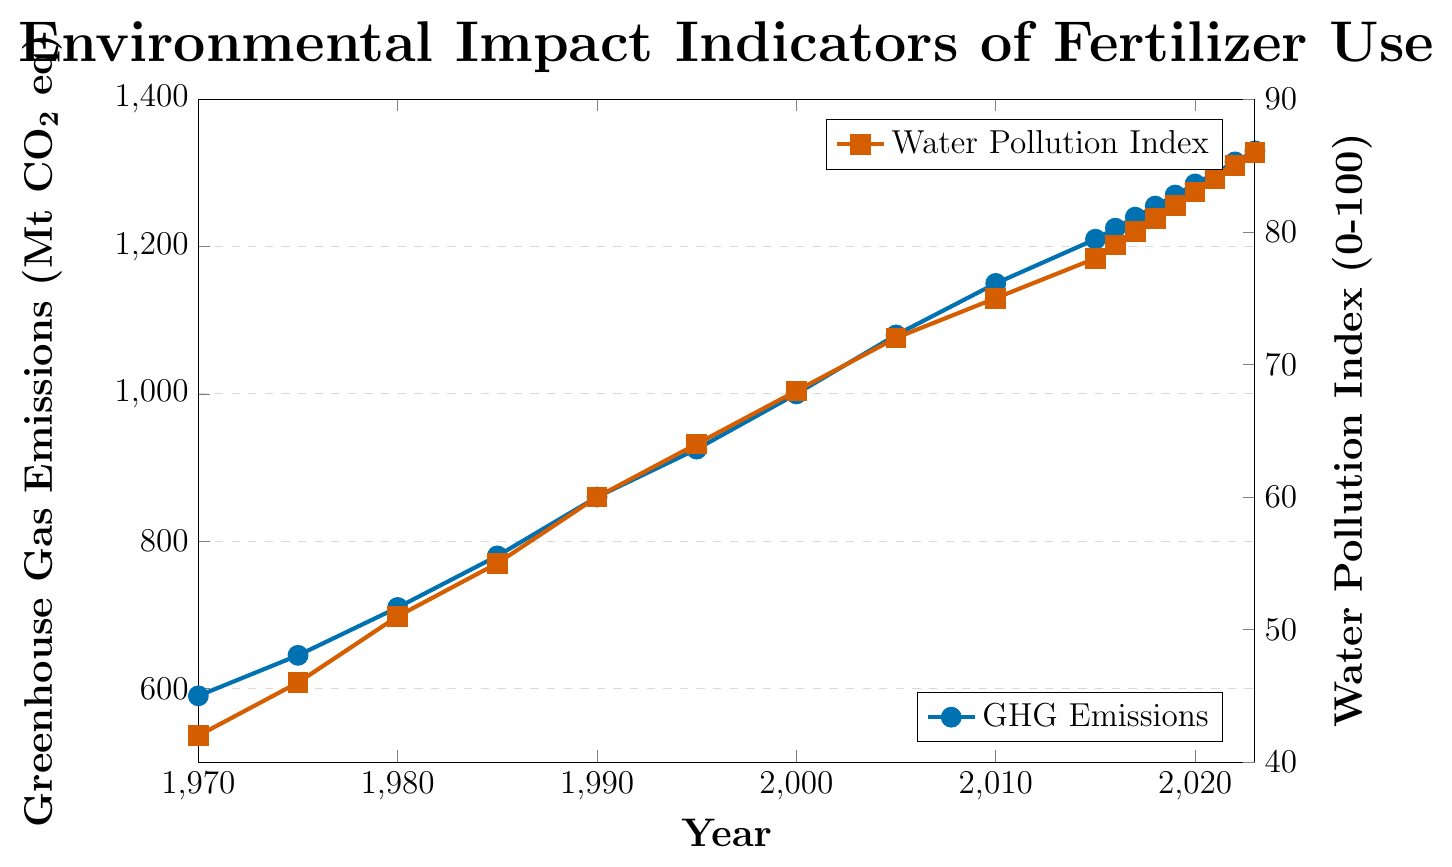What's the increase in Greenhouse Gas Emissions from 1970 to 2023? The Greenhouse Gas Emissions in 1970 was 590 Mt CO2 eq and in 2023 it was 1330 Mt CO2 eq. The increase is calculated as 1330 - 590 = 740 Mt CO2 eq.
Answer: 740 Mt CO2 eq How much did the Water Pollution Index increase from 2005 to 2023? The Water Pollution Index in 2005 was 72, and in 2023 it was 86. The increase is calculated as 86 - 72 = 14.
Answer: 14 What is the average Greenhouse Gas Emissions between 1990 and 2000? Adding the emissions from each year between 1990 and 2000 and then dividing by the number of years: (860 + 925 + 1000) / 3 = 2785 / 3 = 928.33 Mt CO2 eq
Answer: 928.33 Mt CO2 eq In which year did the Water Pollution Index first reach 60? By looking at the chart, the Water Pollution Index first reached 60 in the year 1990.
Answer: 1990 Compare the trend of Greenhouse Gas Emissions and the Water Pollution Index between 2015 and 2023. From 2015 to 2023, Greenhouse Gas Emissions increased from 1210 to 1330 Mt CO2 eq. For the same period, the Water Pollution Index increased from 78 to 86. Both indicators show an increasing trend.
Answer: Both increased Which year shows the highest Greenhouse Gas Emissions? The graph shows that the highest Greenhouse Gas Emissions are in the year 2023 with 1330 Mt CO2 eq.
Answer: 2023 What is the compound annual growth rate (CAGR) of Greenhouse Gas Emissions from 1970 to 2023? To find the CAGR: 
1. Calculate the total growth rate: (1330 / 590) = 2.2542
2. The number of years is 2023 - 1970 = 53
3. CAGR formula is: (Ending Value / Beginning Value)^(1/Number of Years) - 1 = (2.2542)^(1/53) - 1 ≈ 0.015 ≈ 1.5%
Answer: 1.5% What is the difference in Water Pollution Index between 1980 and 2000? The Water Pollution Index in 1980 was 51, and in 2000 it was 68. The difference is calculated as 68 - 51 = 17.
Answer: 17 When did the Water Pollution Index first surpass 80? By observing the chart, the Water Pollution Index first surpassed 80 in the year 2017 when it reached 80.
Answer: 2017 